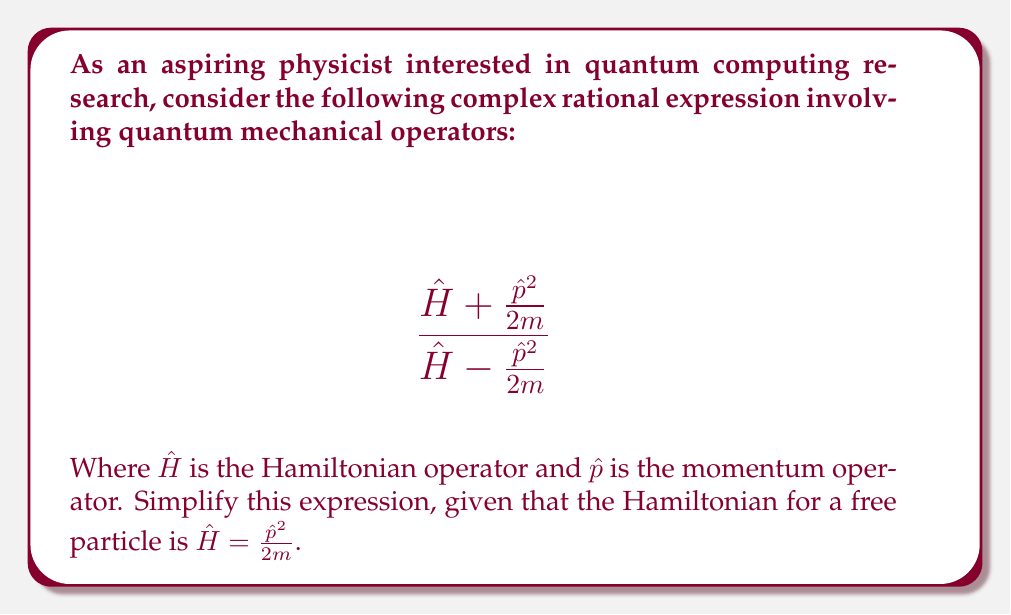Give your solution to this math problem. Let's simplify this expression step-by-step:

1) First, recall that for a free particle, $\hat{H} = \frac{\hat{p}^2}{2m}$. We can use this to substitute for $\hat{H}$ in both the numerator and denominator:

   $$ \frac{\frac{\hat{p}^2}{2m} + \frac{\hat{p}^2}{2m}}{\frac{\hat{p}^2}{2m} - \frac{\hat{p}^2}{2m}} $$

2) Now, let's simplify the numerator and denominator separately:

   Numerator: $\frac{\hat{p}^2}{2m} + \frac{\hat{p}^2}{2m} = \frac{2\hat{p}^2}{2m} = \frac{\hat{p}^2}{m}$

   Denominator: $\frac{\hat{p}^2}{2m} - \frac{\hat{p}^2}{2m} = 0$

3) Our expression now looks like:

   $$ \frac{\frac{\hat{p}^2}{m}}{0} $$

4) However, division by zero is undefined. In the context of quantum mechanics, this result suggests that the original expression is not well-defined for a free particle.

5) We can interpret this result physically: The original expression was asking us to compare the sum and difference of the total energy ($\hat{H}$) and the kinetic energy ($\frac{\hat{p}^2}{2m}$). For a free particle, these are identical, so their difference is zero, leading to the undefined result.
Answer: Undefined (division by zero) 